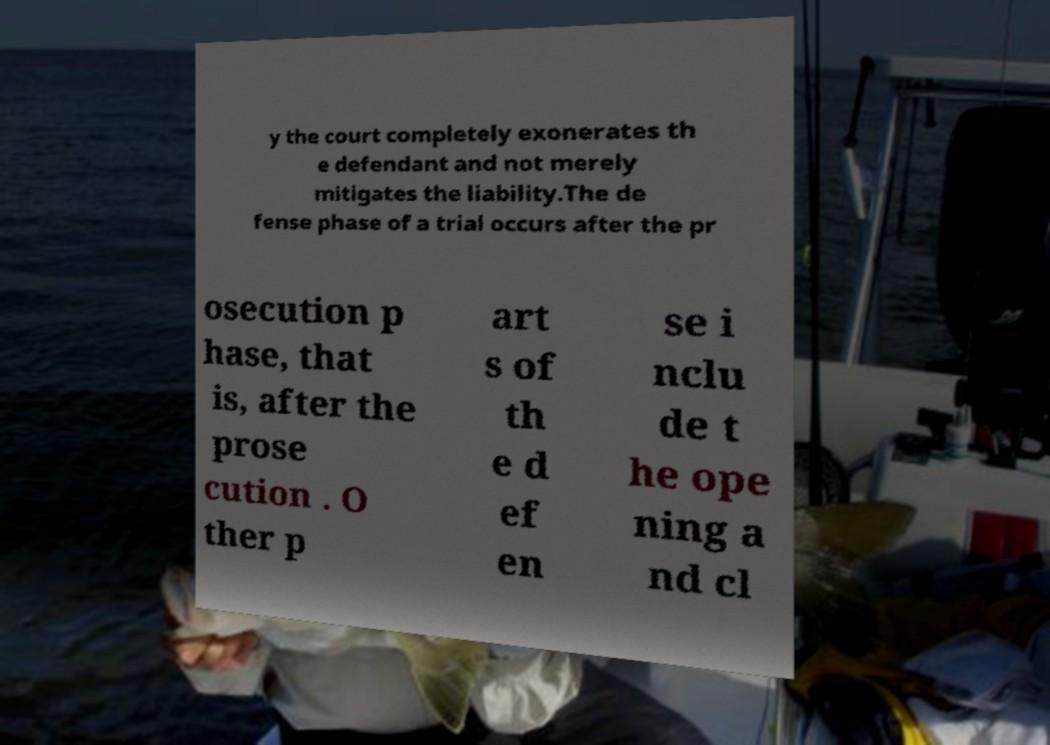Please read and relay the text visible in this image. What does it say? y the court completely exonerates th e defendant and not merely mitigates the liability.The de fense phase of a trial occurs after the pr osecution p hase, that is, after the prose cution . O ther p art s of th e d ef en se i nclu de t he ope ning a nd cl 